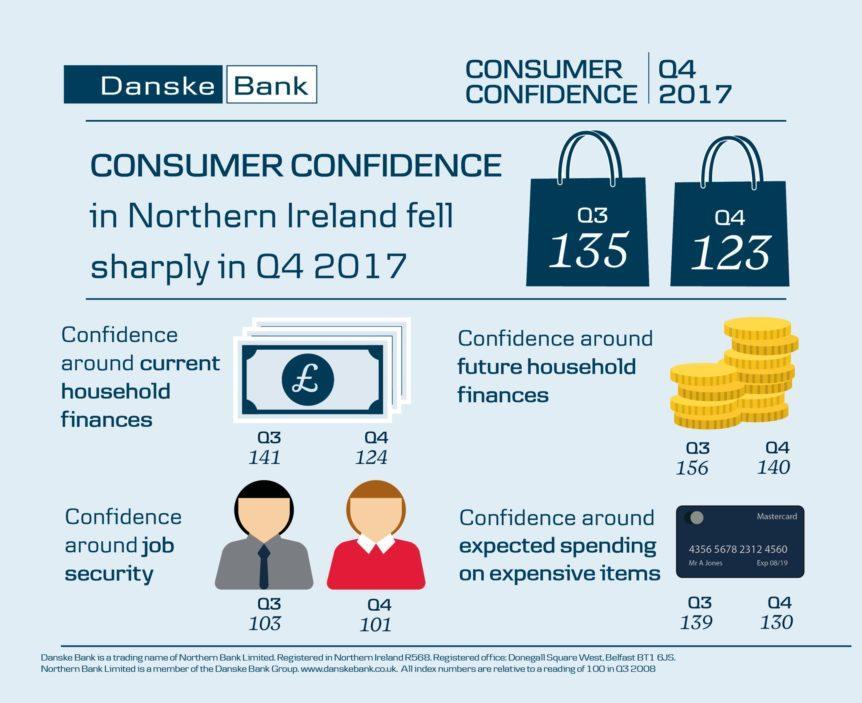List a handful of essential elements in this visual. During the fourth quarter of the year, the consumer confidence in Ireland was recorded at 123. The difference in expected spending on expensive items between quarter 3 and quarter 4 was 9%. The last four digits on the card are 4560. The financial services corporation mentioned on the card is Mastercard. 